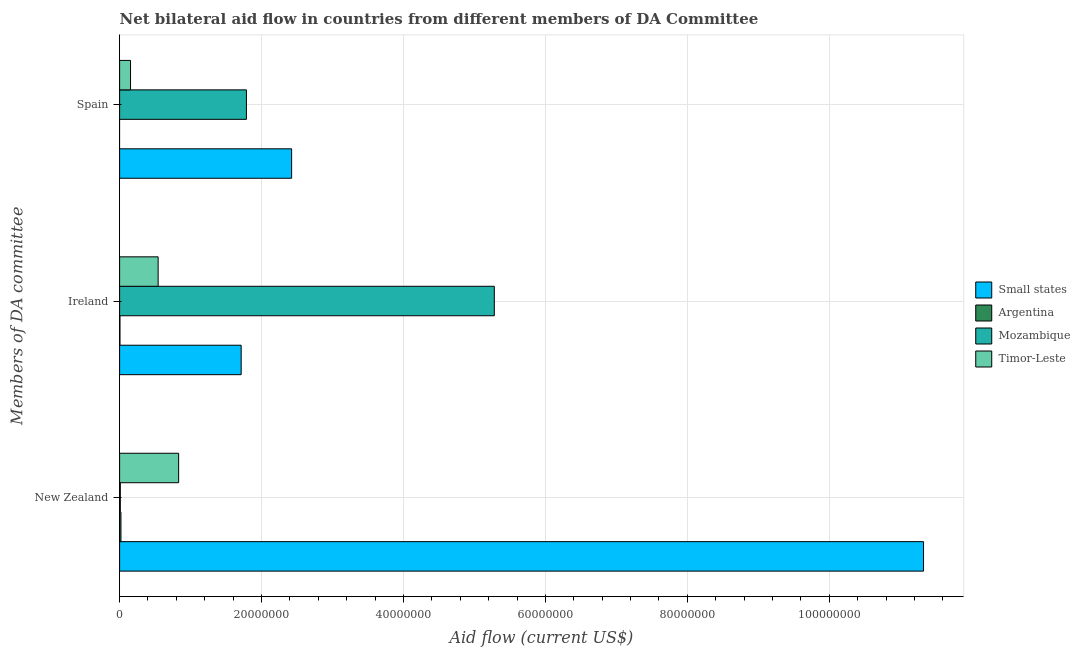How many groups of bars are there?
Make the answer very short. 3. Are the number of bars per tick equal to the number of legend labels?
Offer a very short reply. No. What is the label of the 2nd group of bars from the top?
Your answer should be very brief. Ireland. What is the amount of aid provided by new zealand in Small states?
Offer a terse response. 1.13e+08. Across all countries, what is the maximum amount of aid provided by spain?
Your answer should be very brief. 2.42e+07. In which country was the amount of aid provided by spain maximum?
Make the answer very short. Small states. What is the total amount of aid provided by spain in the graph?
Offer a terse response. 4.36e+07. What is the difference between the amount of aid provided by ireland in Mozambique and that in Argentina?
Provide a succinct answer. 5.28e+07. What is the difference between the amount of aid provided by spain in Mozambique and the amount of aid provided by ireland in Argentina?
Keep it short and to the point. 1.78e+07. What is the average amount of aid provided by new zealand per country?
Provide a short and direct response. 3.05e+07. What is the difference between the amount of aid provided by new zealand and amount of aid provided by ireland in Argentina?
Keep it short and to the point. 1.40e+05. What is the ratio of the amount of aid provided by ireland in Timor-Leste to that in Small states?
Ensure brevity in your answer.  0.32. Is the amount of aid provided by ireland in Mozambique less than that in Timor-Leste?
Offer a very short reply. No. What is the difference between the highest and the second highest amount of aid provided by new zealand?
Make the answer very short. 1.05e+08. What is the difference between the highest and the lowest amount of aid provided by spain?
Your response must be concise. 2.42e+07. How many bars are there?
Your answer should be very brief. 11. Are all the bars in the graph horizontal?
Your answer should be compact. Yes. Does the graph contain grids?
Offer a very short reply. Yes. Where does the legend appear in the graph?
Make the answer very short. Center right. How many legend labels are there?
Your answer should be very brief. 4. How are the legend labels stacked?
Offer a terse response. Vertical. What is the title of the graph?
Provide a short and direct response. Net bilateral aid flow in countries from different members of DA Committee. Does "Luxembourg" appear as one of the legend labels in the graph?
Ensure brevity in your answer.  No. What is the label or title of the X-axis?
Offer a very short reply. Aid flow (current US$). What is the label or title of the Y-axis?
Your response must be concise. Members of DA committee. What is the Aid flow (current US$) in Small states in New Zealand?
Your answer should be very brief. 1.13e+08. What is the Aid flow (current US$) in Timor-Leste in New Zealand?
Provide a short and direct response. 8.32e+06. What is the Aid flow (current US$) in Small states in Ireland?
Your answer should be very brief. 1.71e+07. What is the Aid flow (current US$) in Argentina in Ireland?
Provide a succinct answer. 5.00e+04. What is the Aid flow (current US$) of Mozambique in Ireland?
Offer a terse response. 5.28e+07. What is the Aid flow (current US$) in Timor-Leste in Ireland?
Keep it short and to the point. 5.43e+06. What is the Aid flow (current US$) of Small states in Spain?
Provide a short and direct response. 2.42e+07. What is the Aid flow (current US$) in Argentina in Spain?
Give a very brief answer. 0. What is the Aid flow (current US$) in Mozambique in Spain?
Provide a short and direct response. 1.79e+07. What is the Aid flow (current US$) of Timor-Leste in Spain?
Provide a short and direct response. 1.54e+06. Across all Members of DA committee, what is the maximum Aid flow (current US$) of Small states?
Your answer should be compact. 1.13e+08. Across all Members of DA committee, what is the maximum Aid flow (current US$) of Argentina?
Your answer should be compact. 1.90e+05. Across all Members of DA committee, what is the maximum Aid flow (current US$) of Mozambique?
Ensure brevity in your answer.  5.28e+07. Across all Members of DA committee, what is the maximum Aid flow (current US$) of Timor-Leste?
Provide a succinct answer. 8.32e+06. Across all Members of DA committee, what is the minimum Aid flow (current US$) in Small states?
Your response must be concise. 1.71e+07. Across all Members of DA committee, what is the minimum Aid flow (current US$) of Mozambique?
Offer a terse response. 1.00e+05. Across all Members of DA committee, what is the minimum Aid flow (current US$) in Timor-Leste?
Offer a terse response. 1.54e+06. What is the total Aid flow (current US$) in Small states in the graph?
Ensure brevity in your answer.  1.55e+08. What is the total Aid flow (current US$) in Argentina in the graph?
Ensure brevity in your answer.  2.40e+05. What is the total Aid flow (current US$) in Mozambique in the graph?
Make the answer very short. 7.08e+07. What is the total Aid flow (current US$) of Timor-Leste in the graph?
Your answer should be compact. 1.53e+07. What is the difference between the Aid flow (current US$) of Small states in New Zealand and that in Ireland?
Your answer should be very brief. 9.62e+07. What is the difference between the Aid flow (current US$) of Argentina in New Zealand and that in Ireland?
Ensure brevity in your answer.  1.40e+05. What is the difference between the Aid flow (current US$) in Mozambique in New Zealand and that in Ireland?
Your answer should be very brief. -5.27e+07. What is the difference between the Aid flow (current US$) of Timor-Leste in New Zealand and that in Ireland?
Your response must be concise. 2.89e+06. What is the difference between the Aid flow (current US$) of Small states in New Zealand and that in Spain?
Keep it short and to the point. 8.90e+07. What is the difference between the Aid flow (current US$) in Mozambique in New Zealand and that in Spain?
Offer a very short reply. -1.78e+07. What is the difference between the Aid flow (current US$) of Timor-Leste in New Zealand and that in Spain?
Your answer should be very brief. 6.78e+06. What is the difference between the Aid flow (current US$) in Small states in Ireland and that in Spain?
Ensure brevity in your answer.  -7.11e+06. What is the difference between the Aid flow (current US$) of Mozambique in Ireland and that in Spain?
Ensure brevity in your answer.  3.49e+07. What is the difference between the Aid flow (current US$) in Timor-Leste in Ireland and that in Spain?
Ensure brevity in your answer.  3.89e+06. What is the difference between the Aid flow (current US$) of Small states in New Zealand and the Aid flow (current US$) of Argentina in Ireland?
Your answer should be very brief. 1.13e+08. What is the difference between the Aid flow (current US$) in Small states in New Zealand and the Aid flow (current US$) in Mozambique in Ireland?
Provide a short and direct response. 6.05e+07. What is the difference between the Aid flow (current US$) of Small states in New Zealand and the Aid flow (current US$) of Timor-Leste in Ireland?
Your answer should be compact. 1.08e+08. What is the difference between the Aid flow (current US$) of Argentina in New Zealand and the Aid flow (current US$) of Mozambique in Ireland?
Your answer should be very brief. -5.26e+07. What is the difference between the Aid flow (current US$) of Argentina in New Zealand and the Aid flow (current US$) of Timor-Leste in Ireland?
Keep it short and to the point. -5.24e+06. What is the difference between the Aid flow (current US$) in Mozambique in New Zealand and the Aid flow (current US$) in Timor-Leste in Ireland?
Your answer should be compact. -5.33e+06. What is the difference between the Aid flow (current US$) of Small states in New Zealand and the Aid flow (current US$) of Mozambique in Spain?
Your answer should be very brief. 9.54e+07. What is the difference between the Aid flow (current US$) of Small states in New Zealand and the Aid flow (current US$) of Timor-Leste in Spain?
Provide a succinct answer. 1.12e+08. What is the difference between the Aid flow (current US$) of Argentina in New Zealand and the Aid flow (current US$) of Mozambique in Spain?
Offer a terse response. -1.77e+07. What is the difference between the Aid flow (current US$) in Argentina in New Zealand and the Aid flow (current US$) in Timor-Leste in Spain?
Your answer should be compact. -1.35e+06. What is the difference between the Aid flow (current US$) of Mozambique in New Zealand and the Aid flow (current US$) of Timor-Leste in Spain?
Make the answer very short. -1.44e+06. What is the difference between the Aid flow (current US$) of Small states in Ireland and the Aid flow (current US$) of Mozambique in Spain?
Provide a short and direct response. -7.40e+05. What is the difference between the Aid flow (current US$) of Small states in Ireland and the Aid flow (current US$) of Timor-Leste in Spain?
Offer a terse response. 1.56e+07. What is the difference between the Aid flow (current US$) of Argentina in Ireland and the Aid flow (current US$) of Mozambique in Spain?
Make the answer very short. -1.78e+07. What is the difference between the Aid flow (current US$) in Argentina in Ireland and the Aid flow (current US$) in Timor-Leste in Spain?
Keep it short and to the point. -1.49e+06. What is the difference between the Aid flow (current US$) in Mozambique in Ireland and the Aid flow (current US$) in Timor-Leste in Spain?
Give a very brief answer. 5.13e+07. What is the average Aid flow (current US$) in Small states per Members of DA committee?
Offer a terse response. 5.16e+07. What is the average Aid flow (current US$) in Mozambique per Members of DA committee?
Your answer should be compact. 2.36e+07. What is the average Aid flow (current US$) of Timor-Leste per Members of DA committee?
Give a very brief answer. 5.10e+06. What is the difference between the Aid flow (current US$) of Small states and Aid flow (current US$) of Argentina in New Zealand?
Offer a very short reply. 1.13e+08. What is the difference between the Aid flow (current US$) in Small states and Aid flow (current US$) in Mozambique in New Zealand?
Your answer should be compact. 1.13e+08. What is the difference between the Aid flow (current US$) in Small states and Aid flow (current US$) in Timor-Leste in New Zealand?
Offer a terse response. 1.05e+08. What is the difference between the Aid flow (current US$) of Argentina and Aid flow (current US$) of Mozambique in New Zealand?
Give a very brief answer. 9.00e+04. What is the difference between the Aid flow (current US$) of Argentina and Aid flow (current US$) of Timor-Leste in New Zealand?
Provide a succinct answer. -8.13e+06. What is the difference between the Aid flow (current US$) of Mozambique and Aid flow (current US$) of Timor-Leste in New Zealand?
Ensure brevity in your answer.  -8.22e+06. What is the difference between the Aid flow (current US$) of Small states and Aid flow (current US$) of Argentina in Ireland?
Make the answer very short. 1.71e+07. What is the difference between the Aid flow (current US$) of Small states and Aid flow (current US$) of Mozambique in Ireland?
Provide a succinct answer. -3.57e+07. What is the difference between the Aid flow (current US$) in Small states and Aid flow (current US$) in Timor-Leste in Ireland?
Ensure brevity in your answer.  1.17e+07. What is the difference between the Aid flow (current US$) in Argentina and Aid flow (current US$) in Mozambique in Ireland?
Offer a terse response. -5.28e+07. What is the difference between the Aid flow (current US$) in Argentina and Aid flow (current US$) in Timor-Leste in Ireland?
Ensure brevity in your answer.  -5.38e+06. What is the difference between the Aid flow (current US$) in Mozambique and Aid flow (current US$) in Timor-Leste in Ireland?
Provide a short and direct response. 4.74e+07. What is the difference between the Aid flow (current US$) of Small states and Aid flow (current US$) of Mozambique in Spain?
Ensure brevity in your answer.  6.37e+06. What is the difference between the Aid flow (current US$) in Small states and Aid flow (current US$) in Timor-Leste in Spain?
Your answer should be compact. 2.27e+07. What is the difference between the Aid flow (current US$) of Mozambique and Aid flow (current US$) of Timor-Leste in Spain?
Make the answer very short. 1.63e+07. What is the ratio of the Aid flow (current US$) in Small states in New Zealand to that in Ireland?
Make the answer very short. 6.61. What is the ratio of the Aid flow (current US$) of Argentina in New Zealand to that in Ireland?
Provide a short and direct response. 3.8. What is the ratio of the Aid flow (current US$) in Mozambique in New Zealand to that in Ireland?
Your answer should be very brief. 0. What is the ratio of the Aid flow (current US$) in Timor-Leste in New Zealand to that in Ireland?
Provide a succinct answer. 1.53. What is the ratio of the Aid flow (current US$) of Small states in New Zealand to that in Spain?
Provide a short and direct response. 4.67. What is the ratio of the Aid flow (current US$) of Mozambique in New Zealand to that in Spain?
Ensure brevity in your answer.  0.01. What is the ratio of the Aid flow (current US$) in Timor-Leste in New Zealand to that in Spain?
Offer a very short reply. 5.4. What is the ratio of the Aid flow (current US$) in Small states in Ireland to that in Spain?
Provide a succinct answer. 0.71. What is the ratio of the Aid flow (current US$) of Mozambique in Ireland to that in Spain?
Make the answer very short. 2.95. What is the ratio of the Aid flow (current US$) in Timor-Leste in Ireland to that in Spain?
Ensure brevity in your answer.  3.53. What is the difference between the highest and the second highest Aid flow (current US$) of Small states?
Give a very brief answer. 8.90e+07. What is the difference between the highest and the second highest Aid flow (current US$) of Mozambique?
Your answer should be very brief. 3.49e+07. What is the difference between the highest and the second highest Aid flow (current US$) in Timor-Leste?
Offer a terse response. 2.89e+06. What is the difference between the highest and the lowest Aid flow (current US$) of Small states?
Give a very brief answer. 9.62e+07. What is the difference between the highest and the lowest Aid flow (current US$) of Argentina?
Your answer should be very brief. 1.90e+05. What is the difference between the highest and the lowest Aid flow (current US$) in Mozambique?
Provide a short and direct response. 5.27e+07. What is the difference between the highest and the lowest Aid flow (current US$) of Timor-Leste?
Your answer should be compact. 6.78e+06. 